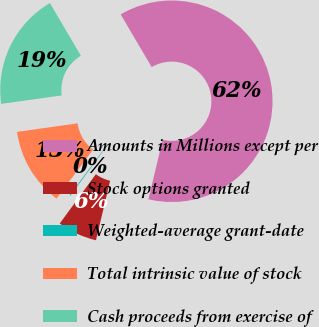<chart> <loc_0><loc_0><loc_500><loc_500><pie_chart><fcel>Amounts in Millions except per<fcel>Stock options granted<fcel>Weighted-average grant-date<fcel>Total intrinsic value of stock<fcel>Cash proceeds from exercise of<nl><fcel>62.19%<fcel>6.35%<fcel>0.15%<fcel>12.56%<fcel>18.76%<nl></chart> 